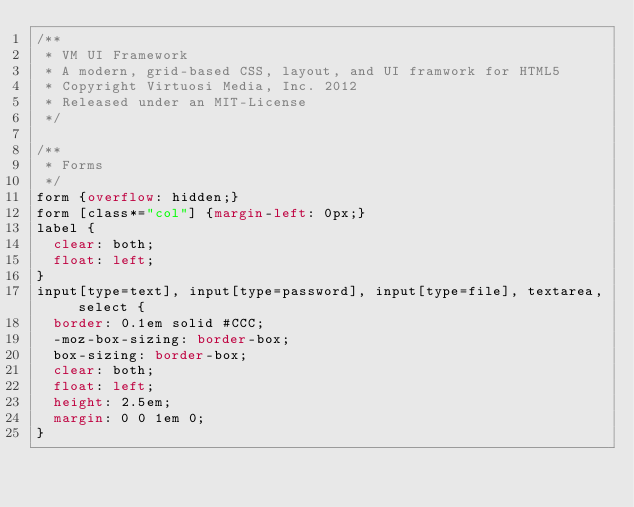Convert code to text. <code><loc_0><loc_0><loc_500><loc_500><_CSS_>/**
 * VM UI Framework
 * A modern, grid-based CSS, layout, and UI framwork for HTML5
 * Copyright Virtuosi Media, Inc. 2012
 * Released under an MIT-License
 */
 
/**
 * Forms
 */
form {overflow: hidden;}
form [class*="col"] {margin-left: 0px;}
label {
	clear: both;
	float: left;
}
input[type=text], input[type=password], input[type=file], textarea, select {
	border: 0.1em solid #CCC;
	-moz-box-sizing: border-box;
	box-sizing: border-box;
	clear: both;
	float: left;
	height: 2.5em;
	margin: 0 0 1em 0;
}</code> 